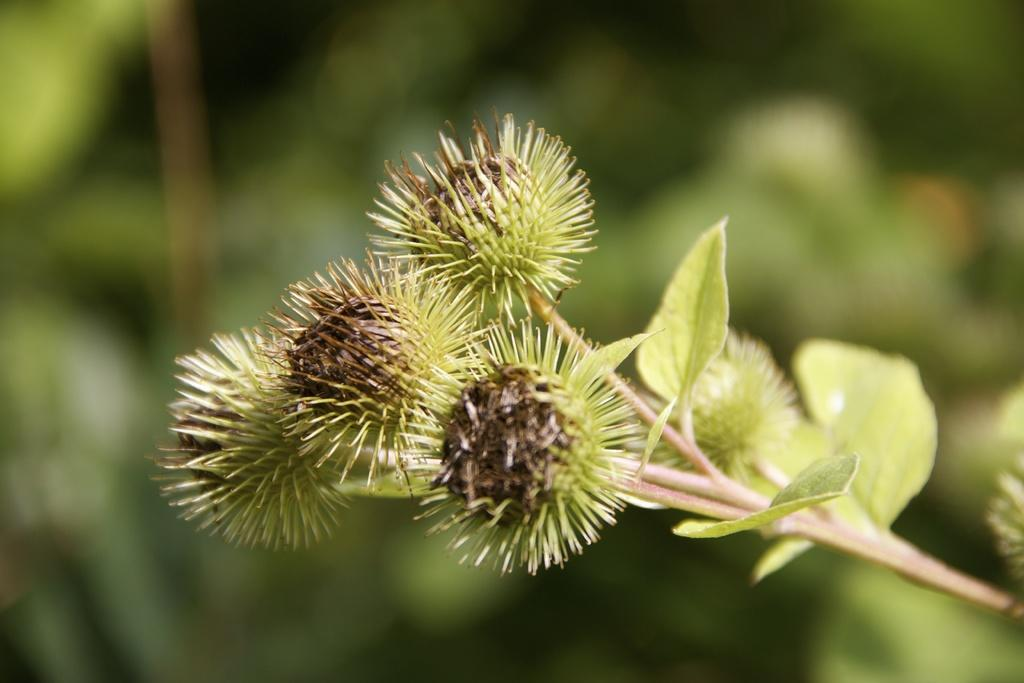What is the main subject of the image? The main subject of the image is a plant. What specific feature can be observed on the plant? The plant has small flowers. How would you describe the background of the image? The background of the image is blurry. What type of company is mentioned in the image? There is no company mentioned in the image; it features a plant with small flowers and a blurry background. 